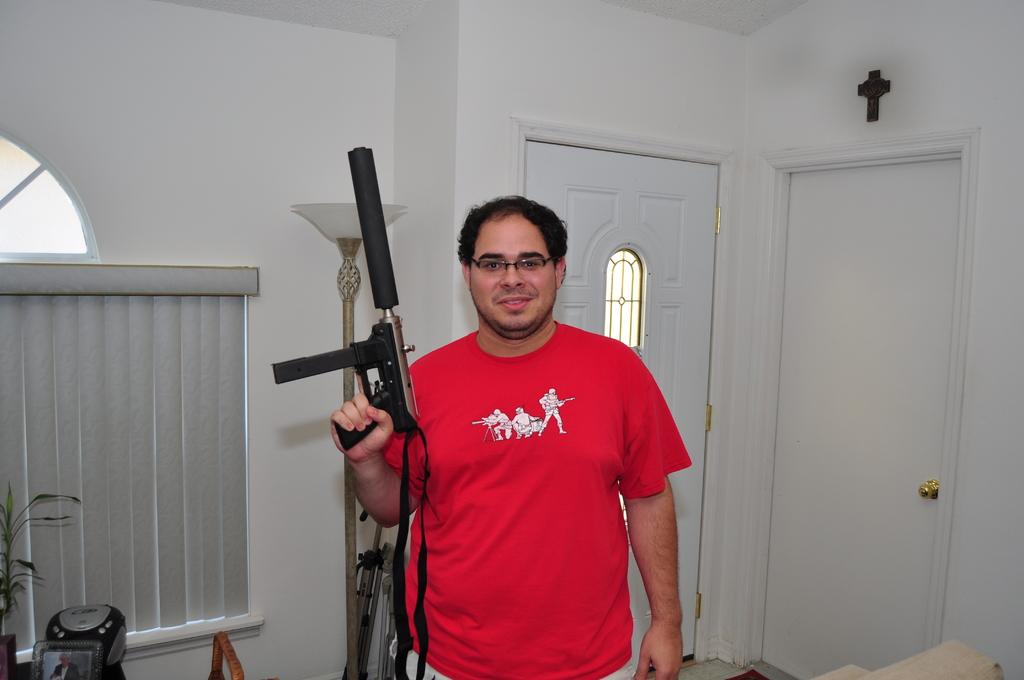What is the person in the image wearing? The person is wearing a red dress. What is the person holding in the image? The person is holding a gun. What color is the door in the image? The door in the image is white. What can be found on the floor in the image? There are objects on the floor in the image. What color is the wall in the image? The wall in the image is white. Where are the flowers located in the image? There are no flowers present in the image. What type of plate is being used by the person in the image? There is no plate visible in the image; the person is holding a gun. 